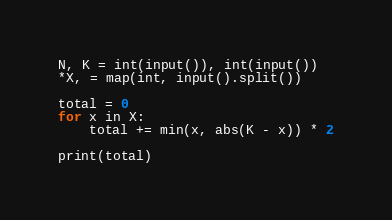Convert code to text. <code><loc_0><loc_0><loc_500><loc_500><_Python_>N, K = int(input()), int(input())
*X, = map(int, input().split())

total = 0
for x in X:
	total += min(x, abs(K - x)) * 2

print(total)
</code> 